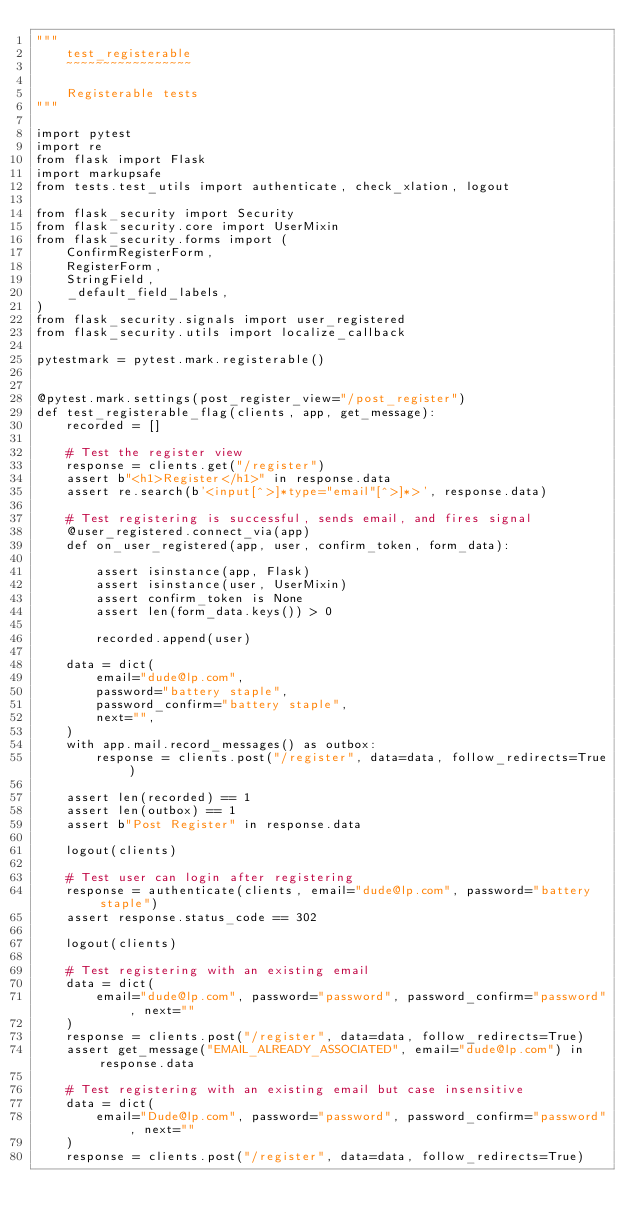Convert code to text. <code><loc_0><loc_0><loc_500><loc_500><_Python_>"""
    test_registerable
    ~~~~~~~~~~~~~~~~~

    Registerable tests
"""

import pytest
import re
from flask import Flask
import markupsafe
from tests.test_utils import authenticate, check_xlation, logout

from flask_security import Security
from flask_security.core import UserMixin
from flask_security.forms import (
    ConfirmRegisterForm,
    RegisterForm,
    StringField,
    _default_field_labels,
)
from flask_security.signals import user_registered
from flask_security.utils import localize_callback

pytestmark = pytest.mark.registerable()


@pytest.mark.settings(post_register_view="/post_register")
def test_registerable_flag(clients, app, get_message):
    recorded = []

    # Test the register view
    response = clients.get("/register")
    assert b"<h1>Register</h1>" in response.data
    assert re.search(b'<input[^>]*type="email"[^>]*>', response.data)

    # Test registering is successful, sends email, and fires signal
    @user_registered.connect_via(app)
    def on_user_registered(app, user, confirm_token, form_data):

        assert isinstance(app, Flask)
        assert isinstance(user, UserMixin)
        assert confirm_token is None
        assert len(form_data.keys()) > 0

        recorded.append(user)

    data = dict(
        email="dude@lp.com",
        password="battery staple",
        password_confirm="battery staple",
        next="",
    )
    with app.mail.record_messages() as outbox:
        response = clients.post("/register", data=data, follow_redirects=True)

    assert len(recorded) == 1
    assert len(outbox) == 1
    assert b"Post Register" in response.data

    logout(clients)

    # Test user can login after registering
    response = authenticate(clients, email="dude@lp.com", password="battery staple")
    assert response.status_code == 302

    logout(clients)

    # Test registering with an existing email
    data = dict(
        email="dude@lp.com", password="password", password_confirm="password", next=""
    )
    response = clients.post("/register", data=data, follow_redirects=True)
    assert get_message("EMAIL_ALREADY_ASSOCIATED", email="dude@lp.com") in response.data

    # Test registering with an existing email but case insensitive
    data = dict(
        email="Dude@lp.com", password="password", password_confirm="password", next=""
    )
    response = clients.post("/register", data=data, follow_redirects=True)</code> 